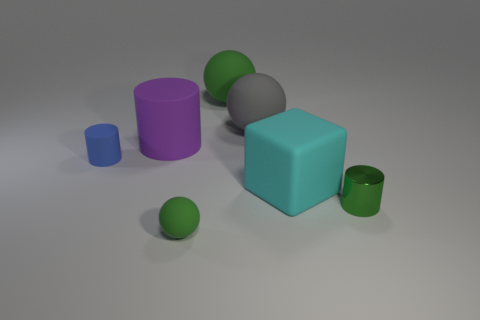Does the tiny green object that is on the right side of the large gray matte sphere have the same material as the large gray ball?
Offer a very short reply. No. What is the size of the object that is behind the tiny blue cylinder and in front of the big gray rubber ball?
Offer a terse response. Large. The metal thing is what color?
Keep it short and to the point. Green. How many large gray objects are there?
Keep it short and to the point. 1. What number of other small cylinders have the same color as the tiny metal cylinder?
Ensure brevity in your answer.  0. Does the green matte object behind the blue thing have the same shape as the tiny green thing that is behind the tiny green sphere?
Make the answer very short. No. The small cylinder that is right of the object that is in front of the cylinder on the right side of the large cyan matte cube is what color?
Ensure brevity in your answer.  Green. The sphere that is in front of the small green metal object is what color?
Offer a very short reply. Green. There is a rubber cylinder that is the same size as the cyan matte thing; what color is it?
Your response must be concise. Purple. Is the size of the gray matte ball the same as the green cylinder?
Provide a short and direct response. No. 